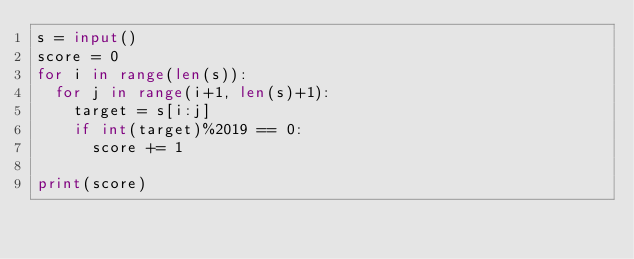<code> <loc_0><loc_0><loc_500><loc_500><_Python_>s = input()
score = 0
for i in range(len(s)):
  for j in range(i+1, len(s)+1):
    target = s[i:j]
    if int(target)%2019 == 0:
      score += 1
      
print(score)</code> 